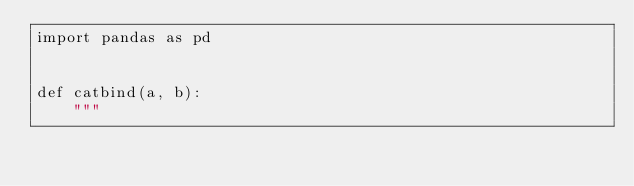<code> <loc_0><loc_0><loc_500><loc_500><_Python_>import pandas as pd


def catbind(a, b):
    """</code> 